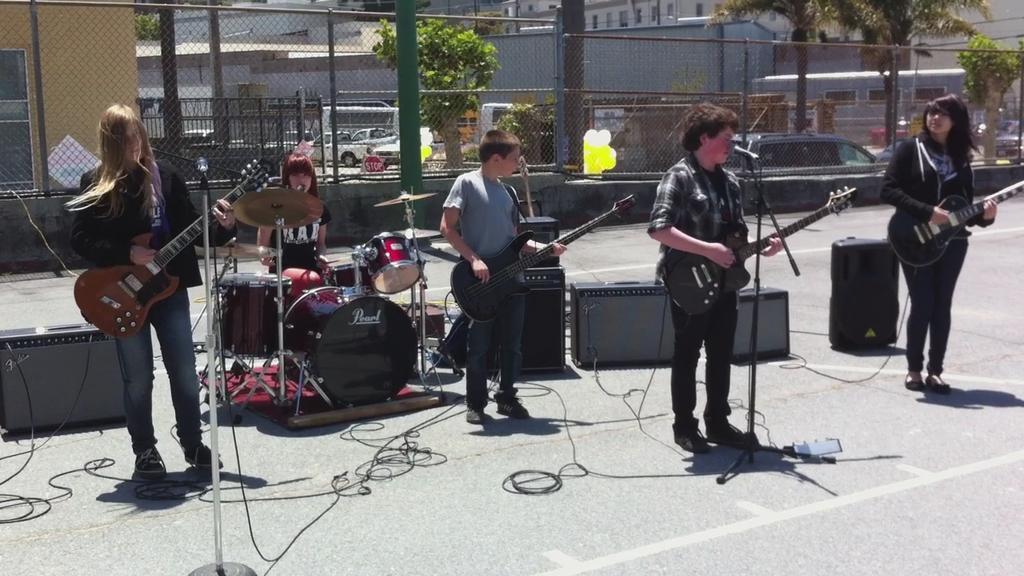Describe this image in one or two sentences. this picture shows a group of people playing guitar´s and singing with the help of a microphone and we see a woman seated and playing drums and we see buildings on their back and couple of trees and we see few cars parked on the side 